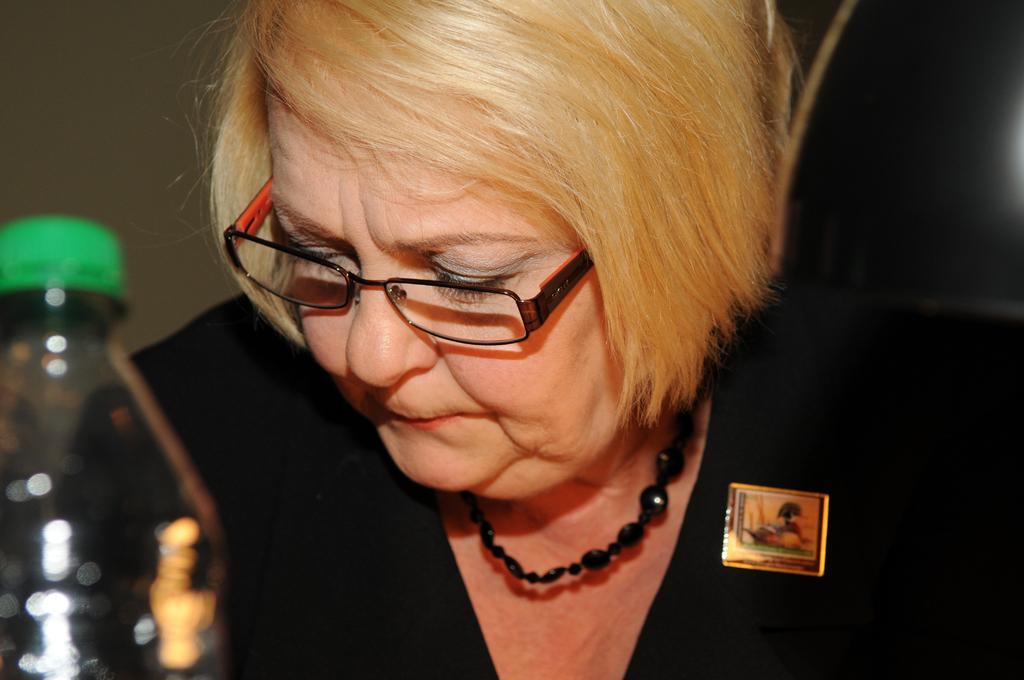Could you give a brief overview of what you see in this image? In this picture there is a women with black dress and spectacles and there is a bottle in front of the women. 